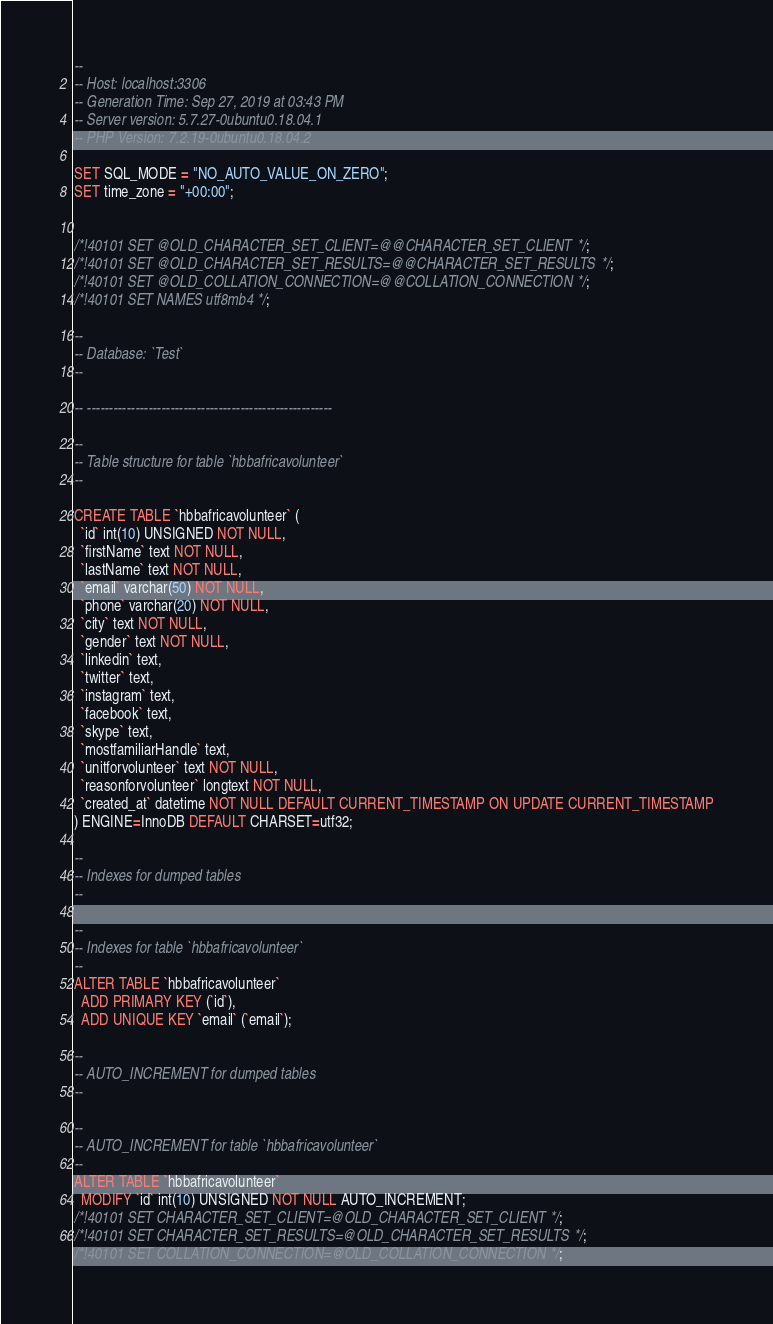Convert code to text. <code><loc_0><loc_0><loc_500><loc_500><_SQL_>--
-- Host: localhost:3306
-- Generation Time: Sep 27, 2019 at 03:43 PM
-- Server version: 5.7.27-0ubuntu0.18.04.1
-- PHP Version: 7.2.19-0ubuntu0.18.04.2

SET SQL_MODE = "NO_AUTO_VALUE_ON_ZERO";
SET time_zone = "+00:00";


/*!40101 SET @OLD_CHARACTER_SET_CLIENT=@@CHARACTER_SET_CLIENT */;
/*!40101 SET @OLD_CHARACTER_SET_RESULTS=@@CHARACTER_SET_RESULTS */;
/*!40101 SET @OLD_COLLATION_CONNECTION=@@COLLATION_CONNECTION */;
/*!40101 SET NAMES utf8mb4 */;

--
-- Database: `Test`
--

-- --------------------------------------------------------

--
-- Table structure for table `hbbafricavolunteer`
--

CREATE TABLE `hbbafricavolunteer` (
  `id` int(10) UNSIGNED NOT NULL,
  `firstName` text NOT NULL,
  `lastName` text NOT NULL,
  `email` varchar(50) NOT NULL,
  `phone` varchar(20) NOT NULL,
  `city` text NOT NULL,
  `gender` text NOT NULL,
  `linkedin` text,
  `twitter` text,
  `instagram` text,
  `facebook` text,
  `skype` text,
  `mostfamiliarHandle` text,
  `unitforvolunteer` text NOT NULL,
  `reasonforvolunteer` longtext NOT NULL,
  `created_at` datetime NOT NULL DEFAULT CURRENT_TIMESTAMP ON UPDATE CURRENT_TIMESTAMP
) ENGINE=InnoDB DEFAULT CHARSET=utf32;

--
-- Indexes for dumped tables
--

--
-- Indexes for table `hbbafricavolunteer`
--
ALTER TABLE `hbbafricavolunteer`
  ADD PRIMARY KEY (`id`),
  ADD UNIQUE KEY `email` (`email`);

--
-- AUTO_INCREMENT for dumped tables
--

--
-- AUTO_INCREMENT for table `hbbafricavolunteer`
--
ALTER TABLE `hbbafricavolunteer`
  MODIFY `id` int(10) UNSIGNED NOT NULL AUTO_INCREMENT;
/*!40101 SET CHARACTER_SET_CLIENT=@OLD_CHARACTER_SET_CLIENT */;
/*!40101 SET CHARACTER_SET_RESULTS=@OLD_CHARACTER_SET_RESULTS */;
/*!40101 SET COLLATION_CONNECTION=@OLD_COLLATION_CONNECTION */;
</code> 